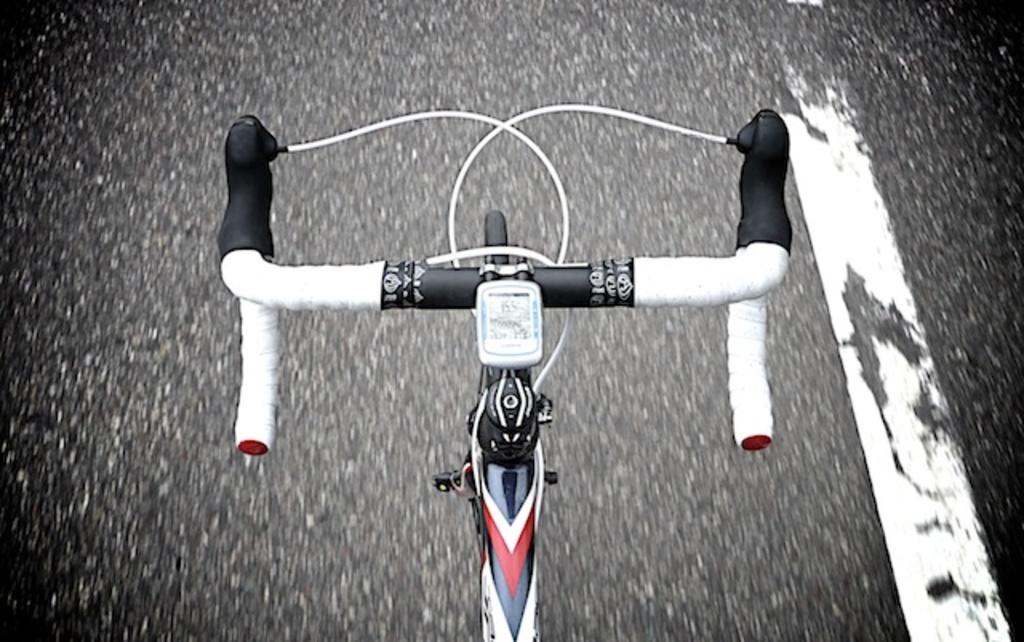What is the main object in the image? There is a cycle in the image. Where is the cycle located? The cycle is on a road. How many forks are visible in the image? There are no forks present in the image. What type of beds can be seen in the image? There are no beds present in the image. 